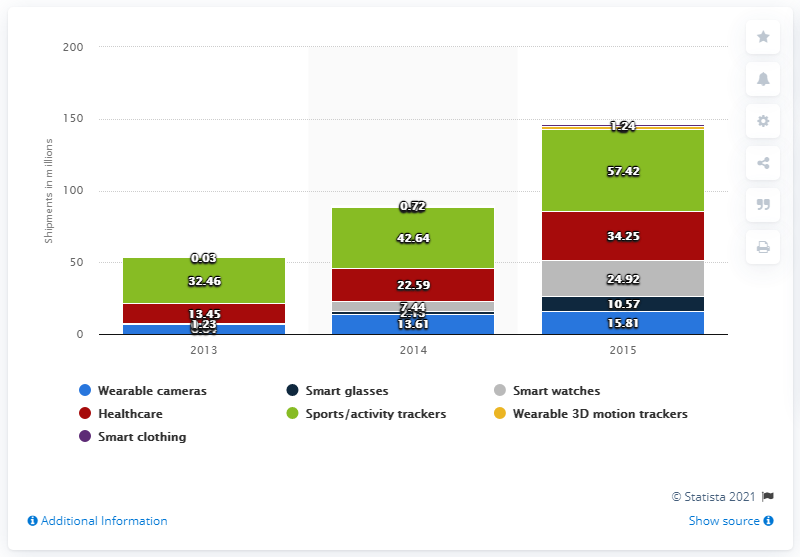Identify some key points in this picture. It is predicted that 10.57 million smart glasses will be shipped in 2015. 